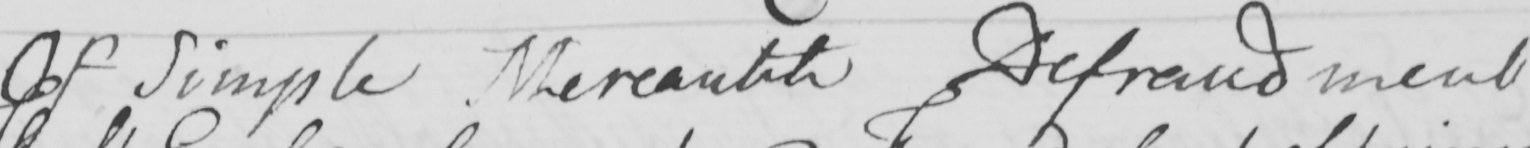Can you read and transcribe this handwriting? Of Simple Mercantile Defraudment 